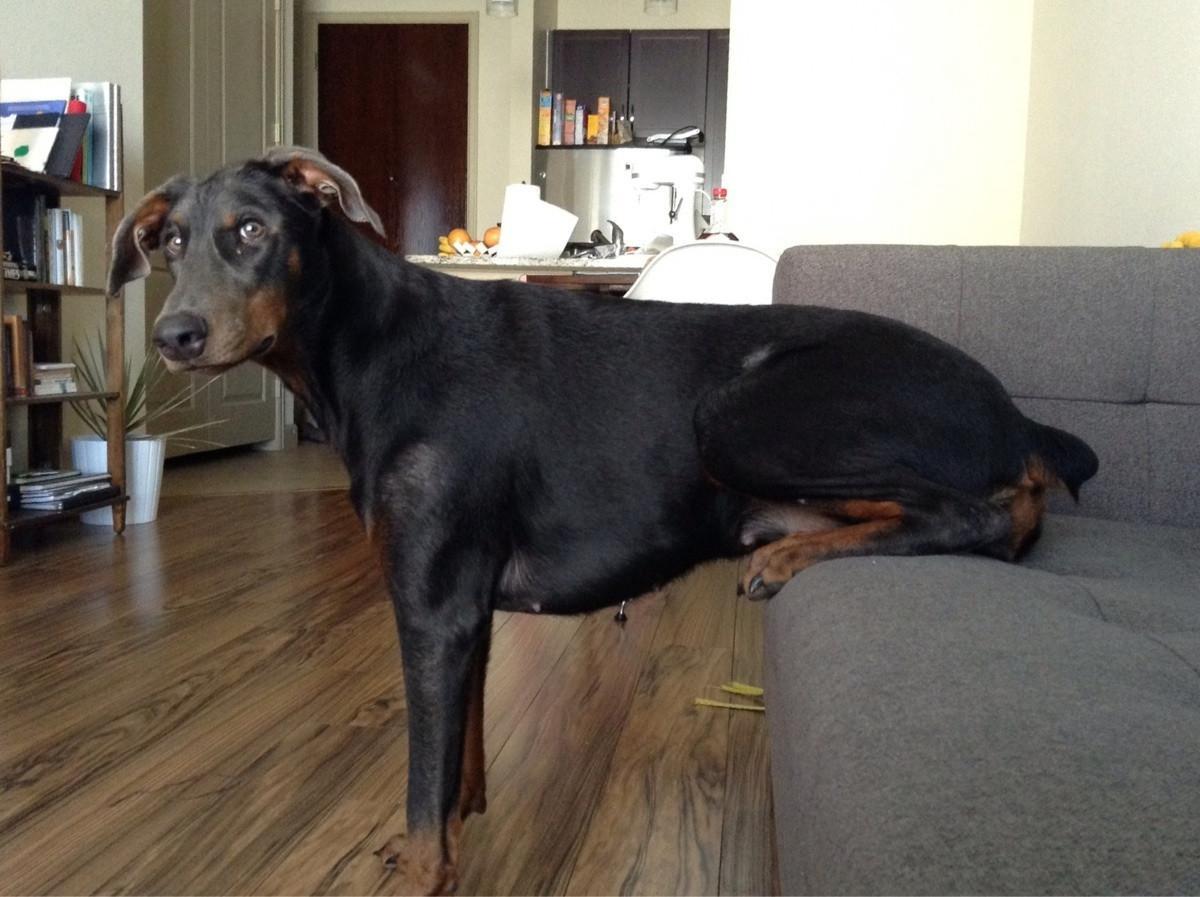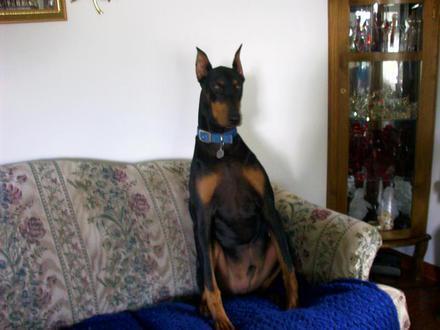The first image is the image on the left, the second image is the image on the right. Examine the images to the left and right. Is the description "The dog in each image is lying on a couch and is asleep." accurate? Answer yes or no. No. The first image is the image on the left, the second image is the image on the right. Considering the images on both sides, is "The left and right image contains the same number of a stretched out dogs using the arm of the sofa as a head rest." valid? Answer yes or no. No. 